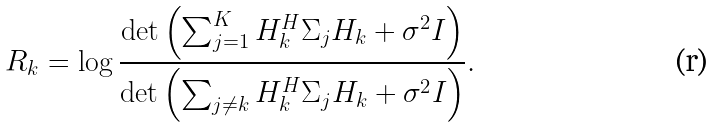<formula> <loc_0><loc_0><loc_500><loc_500>R _ { k } = \log \frac { \det { \left ( \sum _ { j = 1 } ^ { K } H _ { k } ^ { H } \Sigma _ { j } H _ { k } + \sigma ^ { 2 } I \right ) } } { \det { \left ( \sum _ { j \ne k } H _ { k } ^ { H } \Sigma _ { j } H _ { k } + \sigma ^ { 2 } I \right ) } } .</formula> 